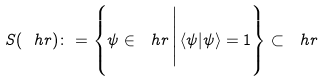<formula> <loc_0><loc_0><loc_500><loc_500>S ( \ h r ) \colon = \left \{ \psi \in \ h r \, \Big | \, \langle \psi | \psi \rangle = 1 \right \} \subset \ h r</formula> 